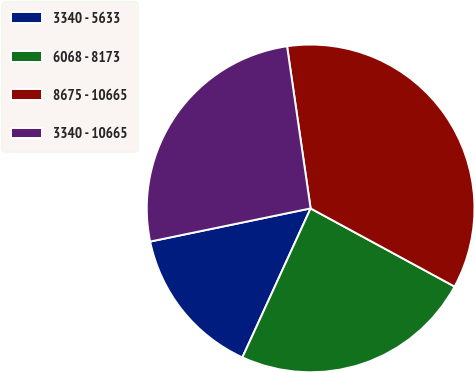Convert chart to OTSL. <chart><loc_0><loc_0><loc_500><loc_500><pie_chart><fcel>3340 - 5633<fcel>6068 - 8173<fcel>8675 - 10665<fcel>3340 - 10665<nl><fcel>14.92%<fcel>23.92%<fcel>35.21%<fcel>25.95%<nl></chart> 